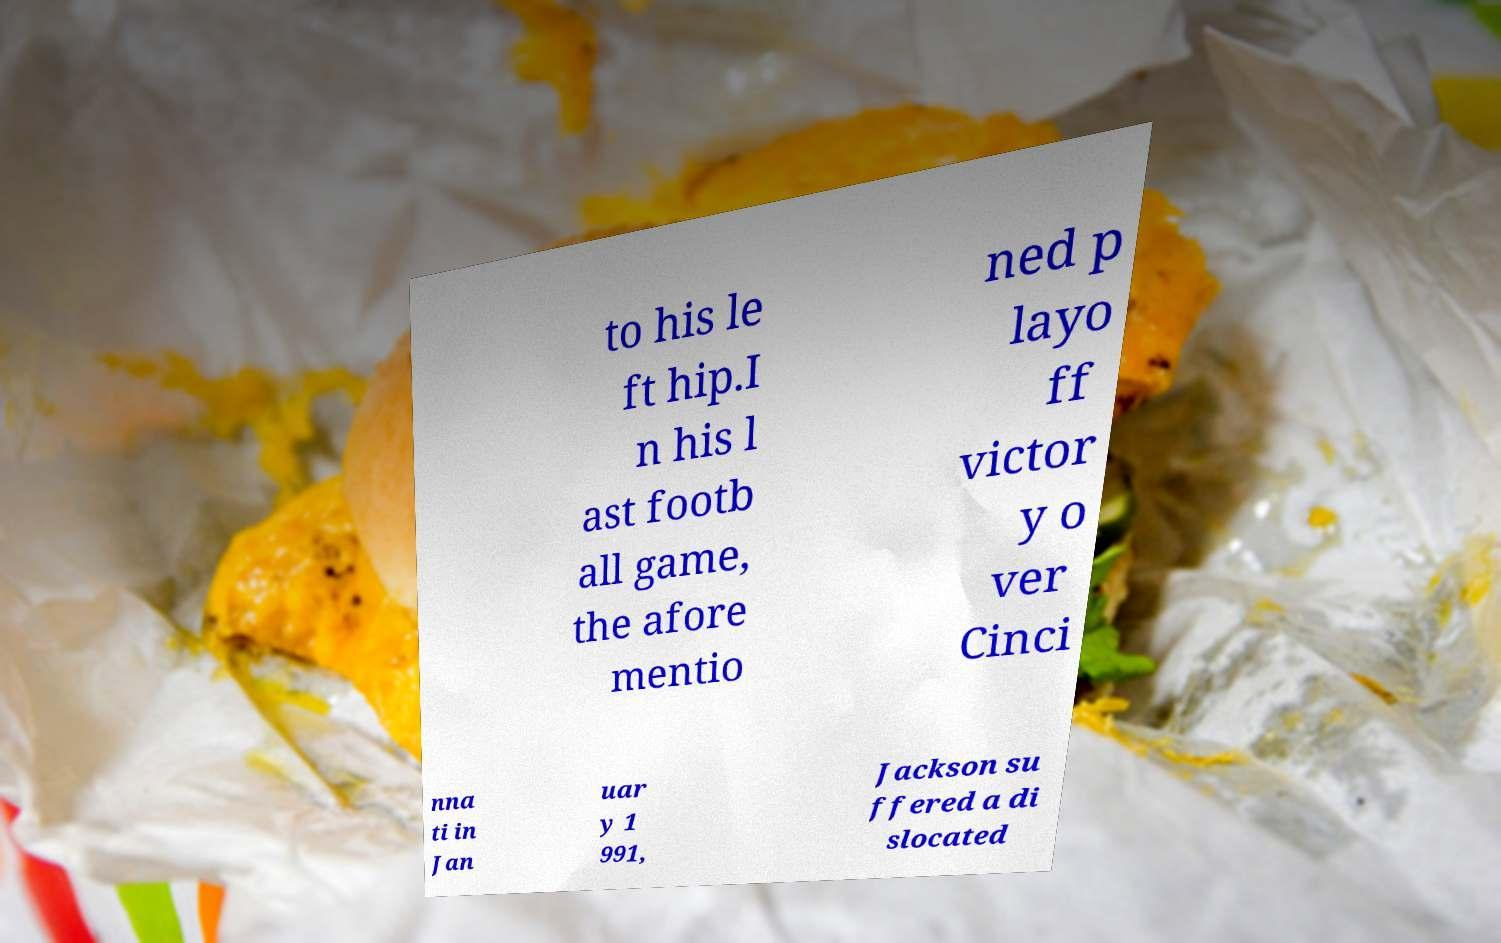Could you assist in decoding the text presented in this image and type it out clearly? to his le ft hip.I n his l ast footb all game, the afore mentio ned p layo ff victor y o ver Cinci nna ti in Jan uar y 1 991, Jackson su ffered a di slocated 